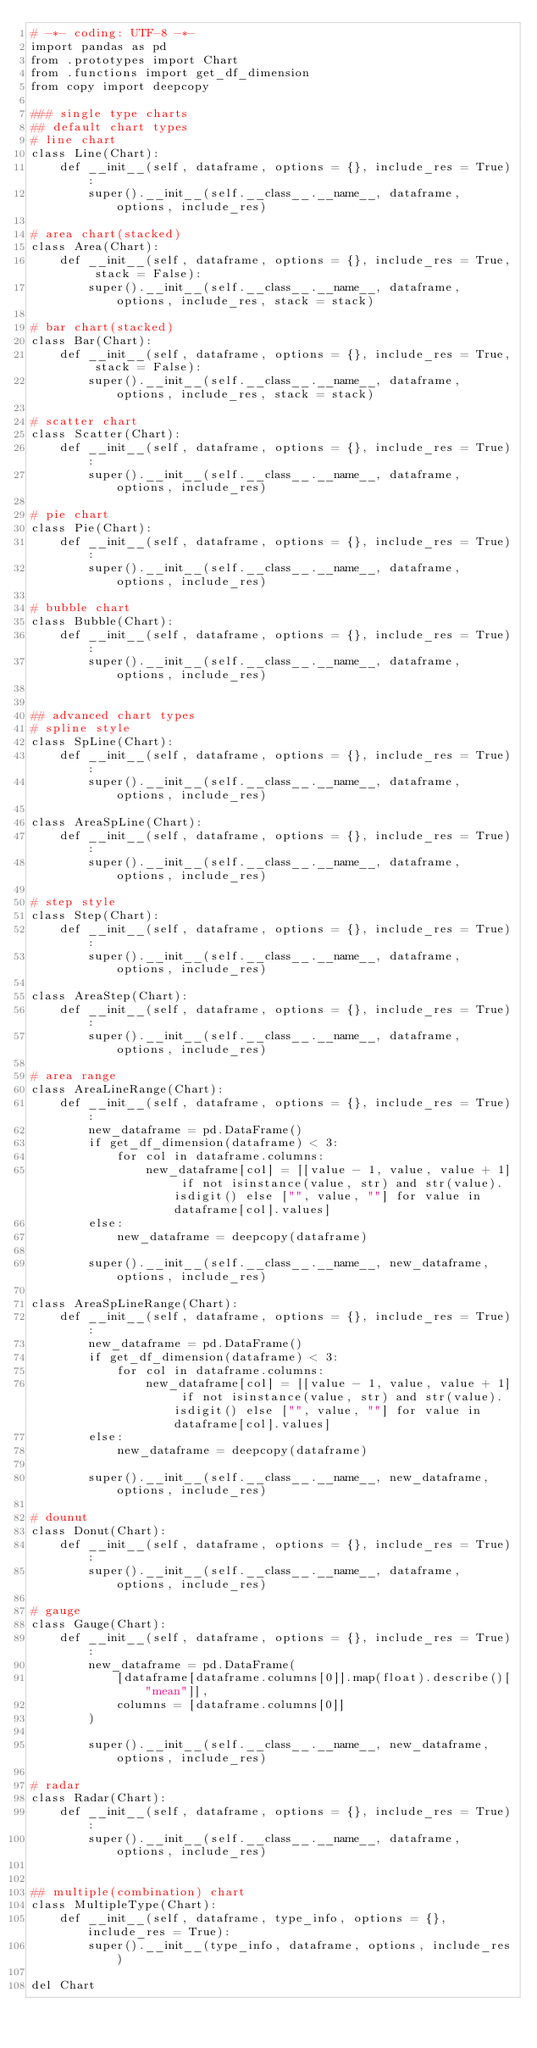<code> <loc_0><loc_0><loc_500><loc_500><_Python_># -*- coding: UTF-8 -*-
import pandas as pd
from .prototypes import Chart
from .functions import get_df_dimension
from copy import deepcopy

### single type charts
## default chart types
# line chart
class Line(Chart):
    def __init__(self, dataframe, options = {}, include_res = True):
        super().__init__(self.__class__.__name__, dataframe, options, include_res)

# area chart(stacked)
class Area(Chart):
    def __init__(self, dataframe, options = {}, include_res = True, stack = False):
        super().__init__(self.__class__.__name__, dataframe, options, include_res, stack = stack)

# bar chart(stacked)
class Bar(Chart):
    def __init__(self, dataframe, options = {}, include_res = True, stack = False):
        super().__init__(self.__class__.__name__, dataframe, options, include_res, stack = stack)

# scatter chart
class Scatter(Chart):
    def __init__(self, dataframe, options = {}, include_res = True):
        super().__init__(self.__class__.__name__, dataframe, options, include_res)

# pie chart
class Pie(Chart):
    def __init__(self, dataframe, options = {}, include_res = True):
        super().__init__(self.__class__.__name__, dataframe, options, include_res)

# bubble chart
class Bubble(Chart):
    def __init__(self, dataframe, options = {}, include_res = True):
        super().__init__(self.__class__.__name__, dataframe, options, include_res)


## advanced chart types
# spline style
class SpLine(Chart):
    def __init__(self, dataframe, options = {}, include_res = True):
        super().__init__(self.__class__.__name__, dataframe, options, include_res)

class AreaSpLine(Chart):
    def __init__(self, dataframe, options = {}, include_res = True):
        super().__init__(self.__class__.__name__, dataframe, options, include_res)

# step style
class Step(Chart):
    def __init__(self, dataframe, options = {}, include_res = True):
        super().__init__(self.__class__.__name__, dataframe, options, include_res)

class AreaStep(Chart):
    def __init__(self, dataframe, options = {}, include_res = True):
        super().__init__(self.__class__.__name__, dataframe, options, include_res)

# area range
class AreaLineRange(Chart):
    def __init__(self, dataframe, options = {}, include_res = True):
        new_dataframe = pd.DataFrame()
        if get_df_dimension(dataframe) < 3:
            for col in dataframe.columns:
                new_dataframe[col] = [[value - 1, value, value + 1] if not isinstance(value, str) and str(value).isdigit() else ["", value, ""] for value in dataframe[col].values]
        else:
            new_dataframe = deepcopy(dataframe)

        super().__init__(self.__class__.__name__, new_dataframe, options, include_res)

class AreaSpLineRange(Chart):
    def __init__(self, dataframe, options = {}, include_res = True):
        new_dataframe = pd.DataFrame()
        if get_df_dimension(dataframe) < 3:
            for col in dataframe.columns:
                new_dataframe[col] = [[value - 1, value, value + 1] if not isinstance(value, str) and str(value).isdigit() else ["", value, ""] for value in dataframe[col].values]
        else:
            new_dataframe = deepcopy(dataframe)

        super().__init__(self.__class__.__name__, new_dataframe, options, include_res)

# dounut
class Donut(Chart):
    def __init__(self, dataframe, options = {}, include_res = True):
        super().__init__(self.__class__.__name__, dataframe, options, include_res)

# gauge
class Gauge(Chart):
    def __init__(self, dataframe, options = {}, include_res = True):
        new_dataframe = pd.DataFrame(
            [dataframe[dataframe.columns[0]].map(float).describe()["mean"]],
            columns = [dataframe.columns[0]]
        )

        super().__init__(self.__class__.__name__, new_dataframe, options, include_res)

# radar
class Radar(Chart):
    def __init__(self, dataframe, options = {}, include_res = True):
        super().__init__(self.__class__.__name__, dataframe, options, include_res)


## multiple(combination) chart
class MultipleType(Chart):
    def __init__(self, dataframe, type_info, options = {}, include_res = True):
        super().__init__(type_info, dataframe, options, include_res)

del Chart</code> 